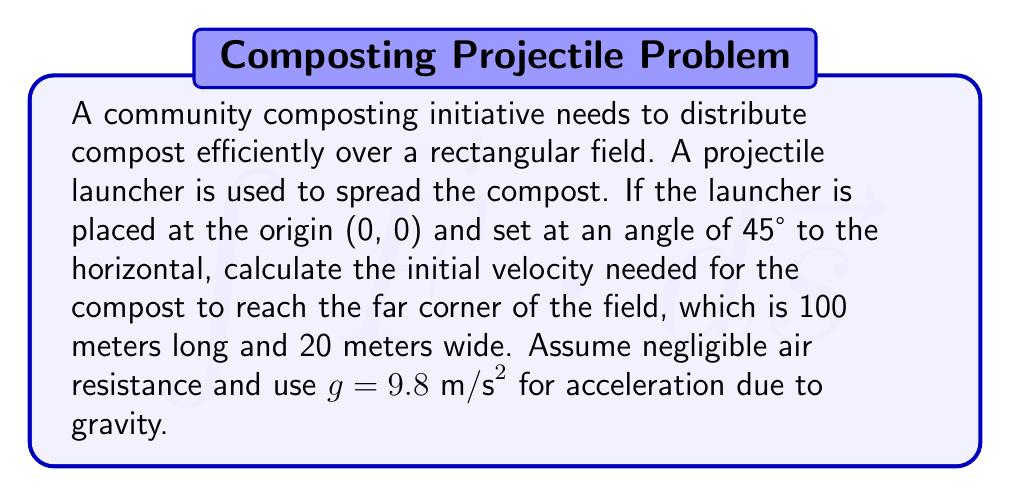Help me with this question. Let's approach this step-by-step:

1) The projectile needs to reach the far corner of the field, which is at coordinates (100, 20).

2) For a projectile launched at 45°, the range equation is:
   $$R = \frac{v_0^2}{g}$$
   where R is the horizontal distance, $v_0$ is the initial velocity, and g is acceleration due to gravity.

3) However, we need to consider both x and y coordinates. The time of flight is:
   $$t = \frac{2v_0 \sin \theta}{g}$$

4) The horizontal distance traveled is:
   $$x = v_0 \cos \theta \cdot t$$

5) The vertical distance traveled is:
   $$y = v_0 \sin \theta \cdot t - \frac{1}{2}gt^2$$

6) We know x = 100 and y = 20. Let's use the x equation:
   $$100 = v_0 \cos 45° \cdot \frac{2v_0 \sin 45°}{g}$$

7) Simplify, knowing $\cos 45° = \sin 45° = \frac{1}{\sqrt{2}}$:
   $$100 = \frac{v_0^2}{g}$$

8) Solve for $v_0$:
   $$v_0 = \sqrt{100g} = \sqrt{100 \cdot 9.8} \approx 31.3 \text{ m/s}$$

9) We should verify this also satisfies the y equation:
   $$20 = 31.3 \sin 45° \cdot \frac{2 \cdot 31.3 \sin 45°}{9.8} - \frac{1}{2} \cdot 9.8 \cdot (\frac{2 \cdot 31.3 \sin 45°}{9.8})^2$$

   This equation holds true, confirming our solution.
Answer: $31.3 \text{ m/s}$ 